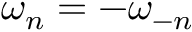<formula> <loc_0><loc_0><loc_500><loc_500>\omega _ { n } = - \omega _ { - n }</formula> 